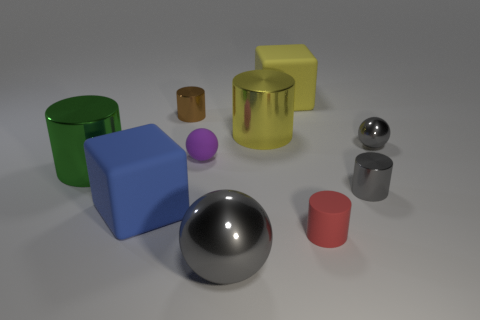Subtract all small matte balls. How many balls are left? 2 Subtract all brown cubes. How many gray spheres are left? 2 Subtract all yellow blocks. How many blocks are left? 1 Subtract all cubes. How many objects are left? 8 Subtract all blue balls. Subtract all green blocks. How many balls are left? 3 Subtract 0 purple cubes. How many objects are left? 10 Subtract 1 balls. How many balls are left? 2 Subtract all small matte cylinders. Subtract all yellow shiny cylinders. How many objects are left? 8 Add 9 red rubber cylinders. How many red rubber cylinders are left? 10 Add 9 small red spheres. How many small red spheres exist? 9 